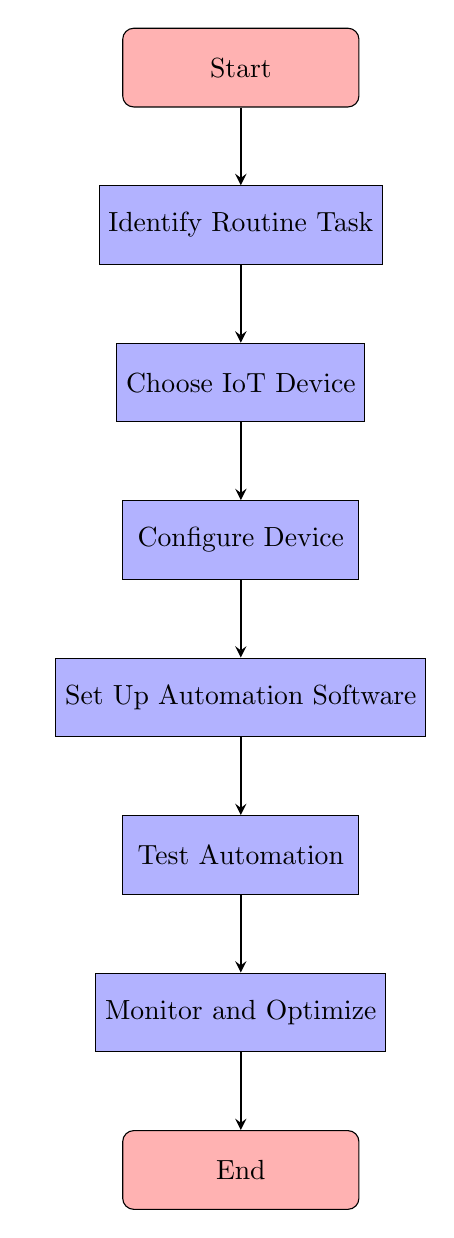What is the first step in the workflow? The first step is represented by the "Start" node, which indicates the beginning of the process.
Answer: Start How many process nodes are there in the diagram? The diagram contains six process nodes, each representing a specific step in the workflow after the starting point.
Answer: 6 What is the last node in the workflow? The last node is the "End" node, signifying the conclusion of the automation process after all other steps.
Answer: End Which node comes after "Test Automation"? After "Test Automation," the next node in the workflow is "Monitor and Optimize," indicating that monitoring comes after testing.
Answer: Monitor and Optimize What comes before "Set Up Automation Software"? The node that comes before "Set Up Automation Software" is "Configure Device," indicating that configuration precedes the setup of software.
Answer: Configure Device How many connections are there in total in the diagram? The total number of connections in the diagram is seven, as they link each of the nodes in the flowchart.
Answer: 7 What is the relationship between "Choose IoT Device" and "Configure Device"? "Choose IoT Device" leads directly to "Configure Device," indicating that once a device is chosen, it is then configured.
Answer: Directly leads to Which process follows the "Identify Routine Task" step? The process that follows "Identify Routine Task" is "Choose IoT Device," showing that after identifying the task, the next step is selecting the appropriate device.
Answer: Choose IoT Device What type of node is "Configure Device"? "Configure Device" is a process node, which indicates it performs a specific action in the workflow rather than being a start or end point.
Answer: Process node 